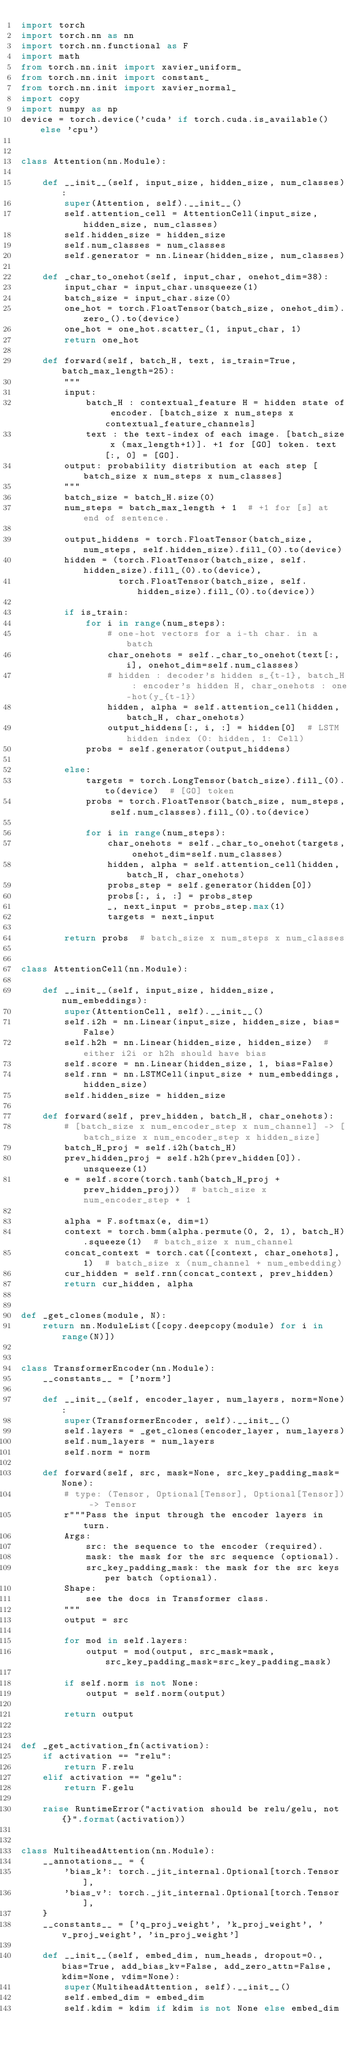Convert code to text. <code><loc_0><loc_0><loc_500><loc_500><_Python_>import torch
import torch.nn as nn
import torch.nn.functional as F
import math
from torch.nn.init import xavier_uniform_
from torch.nn.init import constant_
from torch.nn.init import xavier_normal_
import copy
import numpy as np
device = torch.device('cuda' if torch.cuda.is_available() else 'cpu')


class Attention(nn.Module):

    def __init__(self, input_size, hidden_size, num_classes):
        super(Attention, self).__init__()
        self.attention_cell = AttentionCell(input_size, hidden_size, num_classes)
        self.hidden_size = hidden_size
        self.num_classes = num_classes
        self.generator = nn.Linear(hidden_size, num_classes)

    def _char_to_onehot(self, input_char, onehot_dim=38):
        input_char = input_char.unsqueeze(1)
        batch_size = input_char.size(0)
        one_hot = torch.FloatTensor(batch_size, onehot_dim).zero_().to(device)
        one_hot = one_hot.scatter_(1, input_char, 1)
        return one_hot

    def forward(self, batch_H, text, is_train=True, batch_max_length=25):
        """
        input:
            batch_H : contextual_feature H = hidden state of encoder. [batch_size x num_steps x contextual_feature_channels]
            text : the text-index of each image. [batch_size x (max_length+1)]. +1 for [GO] token. text[:, 0] = [GO].
        output: probability distribution at each step [batch_size x num_steps x num_classes]
        """
        batch_size = batch_H.size(0)
        num_steps = batch_max_length + 1  # +1 for [s] at end of sentence.

        output_hiddens = torch.FloatTensor(batch_size, num_steps, self.hidden_size).fill_(0).to(device)
        hidden = (torch.FloatTensor(batch_size, self.hidden_size).fill_(0).to(device),
                  torch.FloatTensor(batch_size, self.hidden_size).fill_(0).to(device))

        if is_train:
            for i in range(num_steps):
                # one-hot vectors for a i-th char. in a batch
                char_onehots = self._char_to_onehot(text[:, i], onehot_dim=self.num_classes)
                # hidden : decoder's hidden s_{t-1}, batch_H : encoder's hidden H, char_onehots : one-hot(y_{t-1})
                hidden, alpha = self.attention_cell(hidden, batch_H, char_onehots)
                output_hiddens[:, i, :] = hidden[0]  # LSTM hidden index (0: hidden, 1: Cell)
            probs = self.generator(output_hiddens)

        else:
            targets = torch.LongTensor(batch_size).fill_(0).to(device)  # [GO] token
            probs = torch.FloatTensor(batch_size, num_steps, self.num_classes).fill_(0).to(device)

            for i in range(num_steps):
                char_onehots = self._char_to_onehot(targets, onehot_dim=self.num_classes)
                hidden, alpha = self.attention_cell(hidden, batch_H, char_onehots)
                probs_step = self.generator(hidden[0])
                probs[:, i, :] = probs_step
                _, next_input = probs_step.max(1)
                targets = next_input

        return probs  # batch_size x num_steps x num_classes


class AttentionCell(nn.Module):

    def __init__(self, input_size, hidden_size, num_embeddings):
        super(AttentionCell, self).__init__()
        self.i2h = nn.Linear(input_size, hidden_size, bias=False)
        self.h2h = nn.Linear(hidden_size, hidden_size)  # either i2i or h2h should have bias
        self.score = nn.Linear(hidden_size, 1, bias=False)
        self.rnn = nn.LSTMCell(input_size + num_embeddings, hidden_size)
        self.hidden_size = hidden_size

    def forward(self, prev_hidden, batch_H, char_onehots):
        # [batch_size x num_encoder_step x num_channel] -> [batch_size x num_encoder_step x hidden_size]
        batch_H_proj = self.i2h(batch_H)
        prev_hidden_proj = self.h2h(prev_hidden[0]).unsqueeze(1)
        e = self.score(torch.tanh(batch_H_proj + prev_hidden_proj))  # batch_size x num_encoder_step * 1

        alpha = F.softmax(e, dim=1)
        context = torch.bmm(alpha.permute(0, 2, 1), batch_H).squeeze(1)  # batch_size x num_channel
        concat_context = torch.cat([context, char_onehots], 1)  # batch_size x (num_channel + num_embedding)
        cur_hidden = self.rnn(concat_context, prev_hidden)
        return cur_hidden, alpha


def _get_clones(module, N):
    return nn.ModuleList([copy.deepcopy(module) for i in range(N)])


class TransformerEncoder(nn.Module):
    __constants__ = ['norm']

    def __init__(self, encoder_layer, num_layers, norm=None):
        super(TransformerEncoder, self).__init__()
        self.layers = _get_clones(encoder_layer, num_layers)
        self.num_layers = num_layers
        self.norm = norm

    def forward(self, src, mask=None, src_key_padding_mask=None):
        # type: (Tensor, Optional[Tensor], Optional[Tensor]) -> Tensor
        r"""Pass the input through the encoder layers in turn.
        Args:
            src: the sequence to the encoder (required).
            mask: the mask for the src sequence (optional).
            src_key_padding_mask: the mask for the src keys per batch (optional).
        Shape:
            see the docs in Transformer class.
        """
        output = src

        for mod in self.layers:
            output = mod(output, src_mask=mask, src_key_padding_mask=src_key_padding_mask)

        if self.norm is not None:
            output = self.norm(output)

        return output


def _get_activation_fn(activation):
    if activation == "relu":
        return F.relu
    elif activation == "gelu":
        return F.gelu

    raise RuntimeError("activation should be relu/gelu, not {}".format(activation))


class MultiheadAttention(nn.Module):
    __annotations__ = {
        'bias_k': torch._jit_internal.Optional[torch.Tensor],
        'bias_v': torch._jit_internal.Optional[torch.Tensor],
    }
    __constants__ = ['q_proj_weight', 'k_proj_weight', 'v_proj_weight', 'in_proj_weight']

    def __init__(self, embed_dim, num_heads, dropout=0., bias=True, add_bias_kv=False, add_zero_attn=False, kdim=None, vdim=None):
        super(MultiheadAttention, self).__init__()
        self.embed_dim = embed_dim
        self.kdim = kdim if kdim is not None else embed_dim</code> 